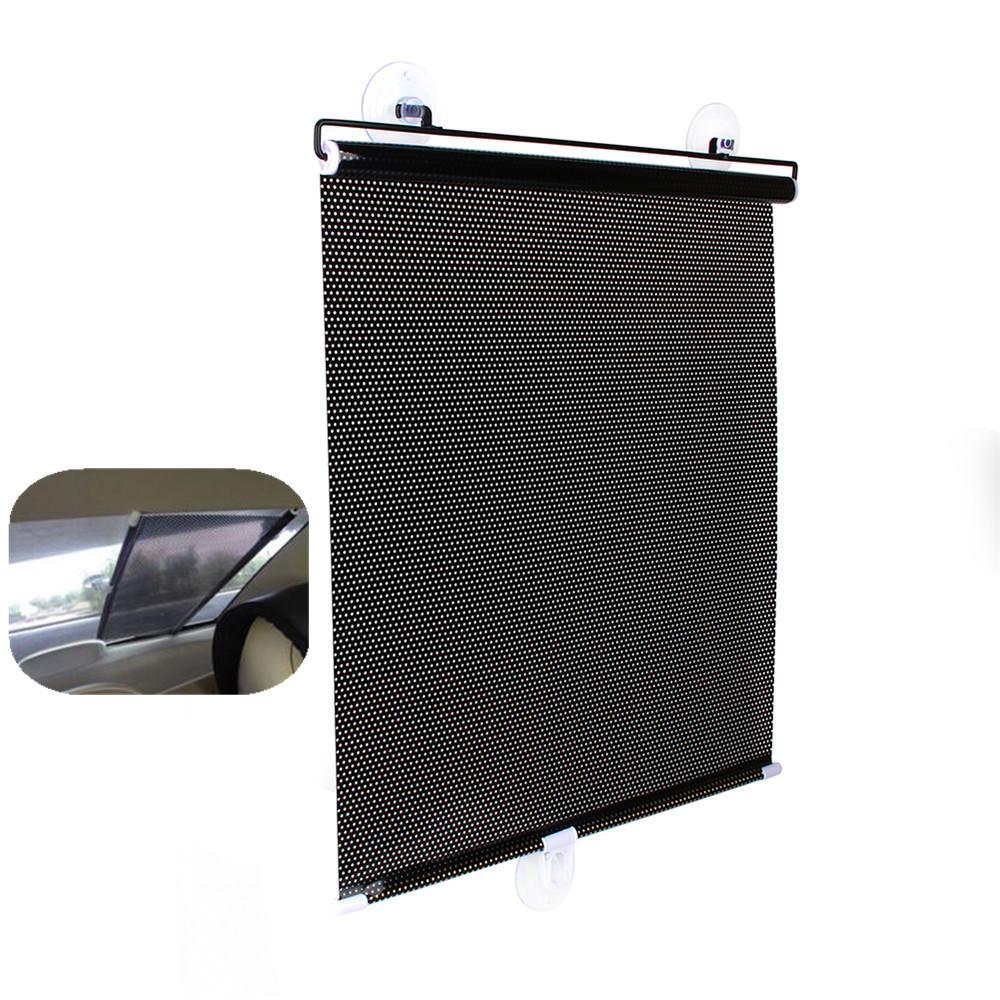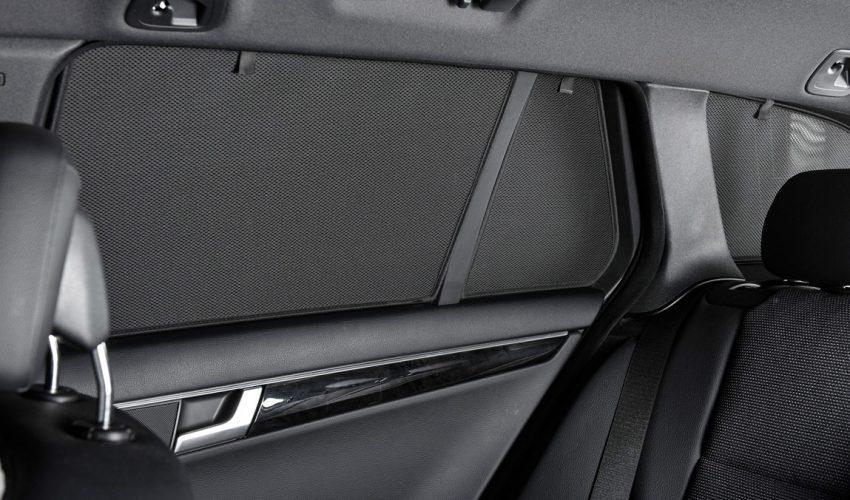The first image is the image on the left, the second image is the image on the right. Examine the images to the left and right. Is the description "The right image shows the vehicle's interior with a shaded window." accurate? Answer yes or no. Yes. 